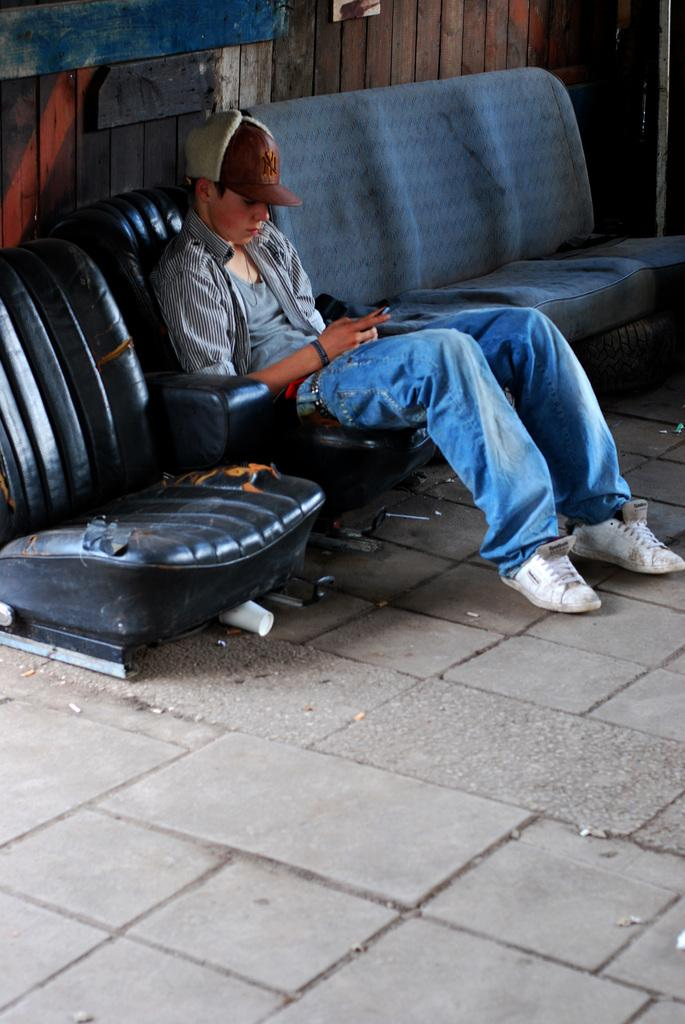Who is in the image? There is a boy in the image. What is the boy doing in the image? The boy is sitting on a chair. What other furniture is visible in the image? There is a sofa beside the boy. What can be seen in the background of the image? There is a wooden wall in the background of the image. Are there any visible coal or tin materials in the image? No, there are no coal or tin materials present in the image. Is there a cobweb hanging from the wooden wall in the image? The image does not show any cobwebs hanging from the wooden wall. 